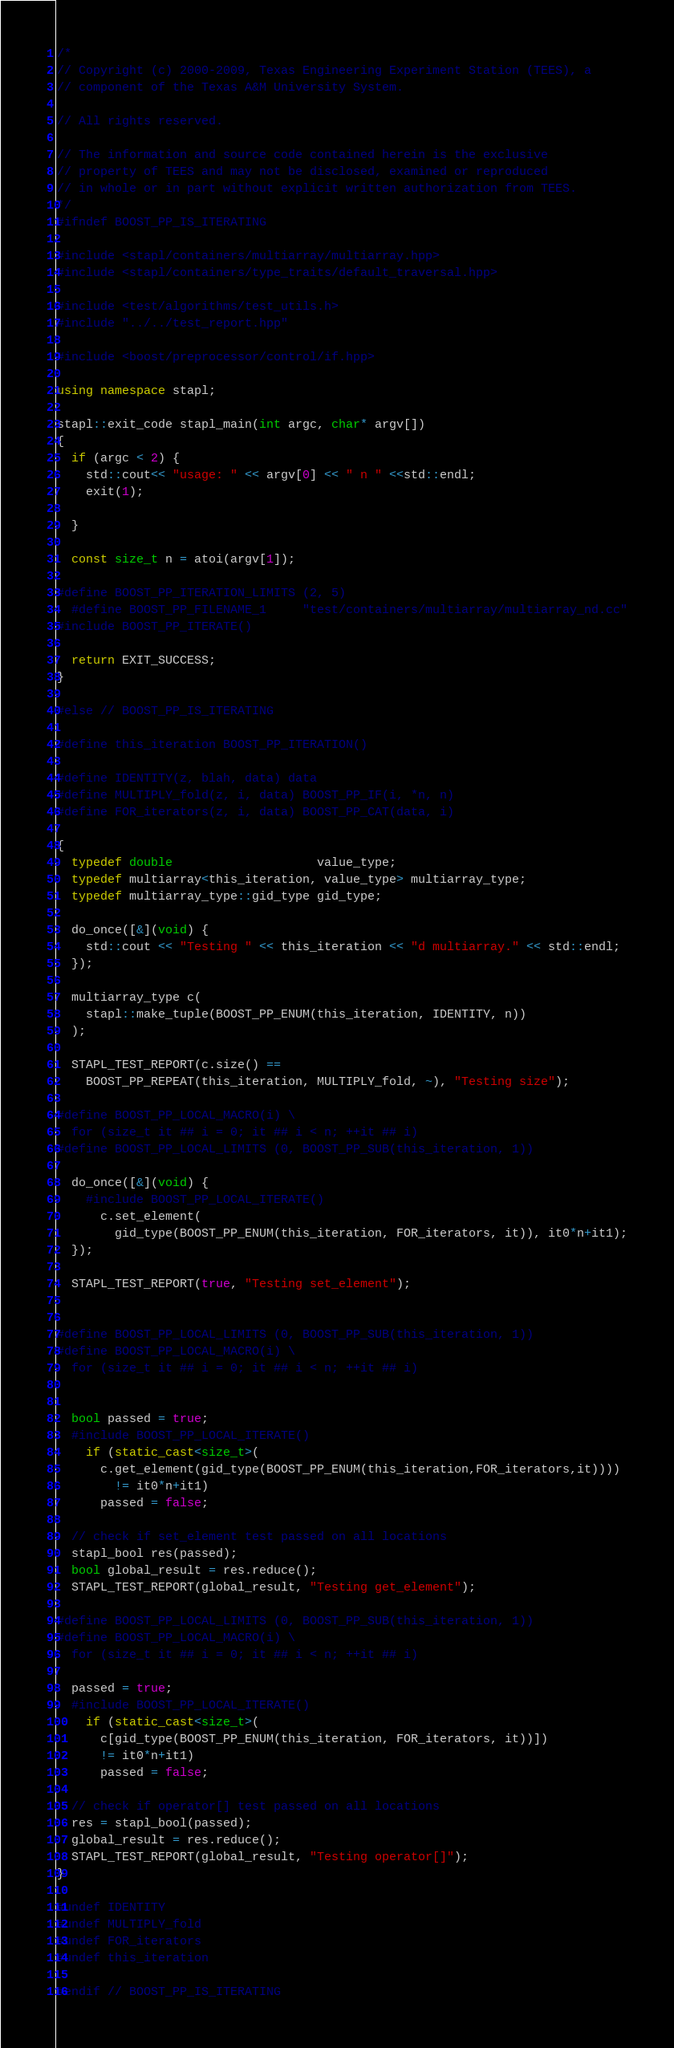<code> <loc_0><loc_0><loc_500><loc_500><_C++_>/*
// Copyright (c) 2000-2009, Texas Engineering Experiment Station (TEES), a
// component of the Texas A&M University System.

// All rights reserved.

// The information and source code contained herein is the exclusive
// property of TEES and may not be disclosed, examined or reproduced
// in whole or in part without explicit written authorization from TEES.
*/
#ifndef BOOST_PP_IS_ITERATING

#include <stapl/containers/multiarray/multiarray.hpp>
#include <stapl/containers/type_traits/default_traversal.hpp>

#include <test/algorithms/test_utils.h>
#include "../../test_report.hpp"

#include <boost/preprocessor/control/if.hpp>

using namespace stapl;

stapl::exit_code stapl_main(int argc, char* argv[])
{
  if (argc < 2) {
    std::cout<< "usage: " << argv[0] << " n " <<std::endl;
    exit(1);

  }

  const size_t n = atoi(argv[1]);

#define BOOST_PP_ITERATION_LIMITS (2, 5)
  #define BOOST_PP_FILENAME_1     "test/containers/multiarray/multiarray_nd.cc"
#include BOOST_PP_ITERATE()

  return EXIT_SUCCESS;
}

#else // BOOST_PP_IS_ITERATING

#define this_iteration BOOST_PP_ITERATION()

#define IDENTITY(z, blah, data) data
#define MULTIPLY_fold(z, i, data) BOOST_PP_IF(i, *n, n)
#define FOR_iterators(z, i, data) BOOST_PP_CAT(data, i)

{
  typedef double                    value_type;
  typedef multiarray<this_iteration, value_type> multiarray_type;
  typedef multiarray_type::gid_type gid_type;

  do_once([&](void) {
    std::cout << "Testing " << this_iteration << "d multiarray." << std::endl;
  });

  multiarray_type c(
    stapl::make_tuple(BOOST_PP_ENUM(this_iteration, IDENTITY, n))
  );

  STAPL_TEST_REPORT(c.size() ==
    BOOST_PP_REPEAT(this_iteration, MULTIPLY_fold, ~), "Testing size");

#define BOOST_PP_LOCAL_MACRO(i) \
  for (size_t it ## i = 0; it ## i < n; ++it ## i)
#define BOOST_PP_LOCAL_LIMITS (0, BOOST_PP_SUB(this_iteration, 1))

  do_once([&](void) {
    #include BOOST_PP_LOCAL_ITERATE()
      c.set_element(
        gid_type(BOOST_PP_ENUM(this_iteration, FOR_iterators, it)), it0*n+it1);
  });

  STAPL_TEST_REPORT(true, "Testing set_element");


#define BOOST_PP_LOCAL_LIMITS (0, BOOST_PP_SUB(this_iteration, 1))
#define BOOST_PP_LOCAL_MACRO(i) \
  for (size_t it ## i = 0; it ## i < n; ++it ## i)


  bool passed = true;
  #include BOOST_PP_LOCAL_ITERATE()
    if (static_cast<size_t>(
      c.get_element(gid_type(BOOST_PP_ENUM(this_iteration,FOR_iterators,it))))
        != it0*n+it1)
      passed = false;

  // check if set_element test passed on all locations
  stapl_bool res(passed);
  bool global_result = res.reduce();
  STAPL_TEST_REPORT(global_result, "Testing get_element");

#define BOOST_PP_LOCAL_LIMITS (0, BOOST_PP_SUB(this_iteration, 1))
#define BOOST_PP_LOCAL_MACRO(i) \
  for (size_t it ## i = 0; it ## i < n; ++it ## i)

  passed = true;
  #include BOOST_PP_LOCAL_ITERATE()
    if (static_cast<size_t>(
      c[gid_type(BOOST_PP_ENUM(this_iteration, FOR_iterators, it))])
      != it0*n+it1)
      passed = false;

  // check if operator[] test passed on all locations
  res = stapl_bool(passed);
  global_result = res.reduce();
  STAPL_TEST_REPORT(global_result, "Testing operator[]");
}

#undef IDENTITY
#undef MULTIPLY_fold
#undef FOR_iterators
#undef this_iteration

#endif // BOOST_PP_IS_ITERATING
</code> 